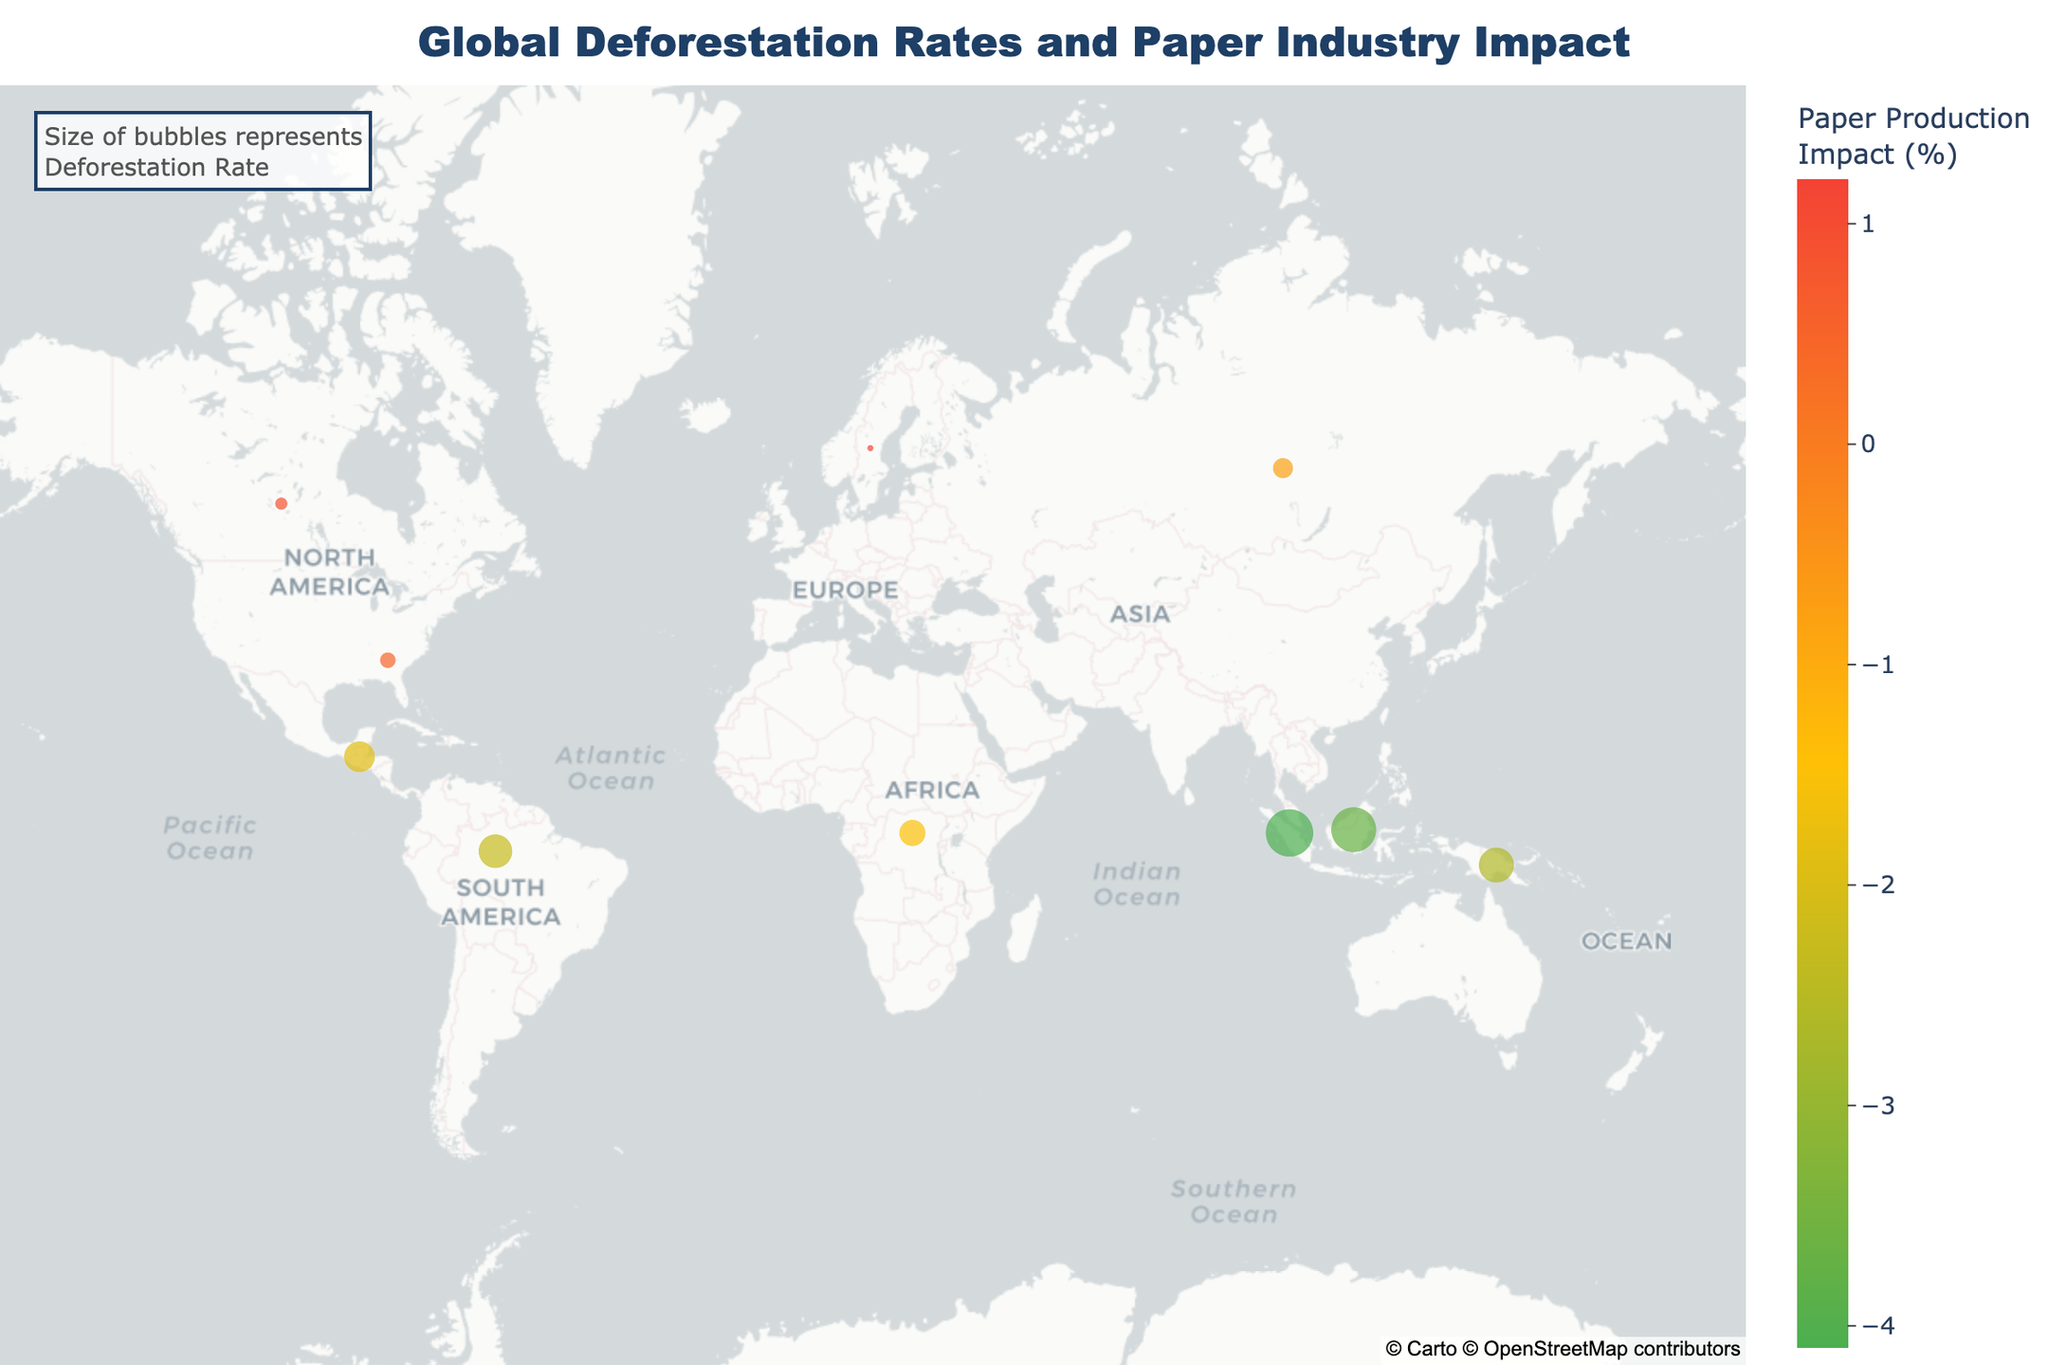What is the title of the figure? The title is usually displayed prominently at the top of the figure. In this case, it reads "Global Deforestation Rates and Paper Industry Impact".
Answer: Global Deforestation Rates and Paper Industry Impact How many regions are shown in the figure? By counting the number of different regions listed in the data or on the map, you can determine the number of regions.
Answer: 10 Which region has the highest deforestation rate? By looking at the size of the bubbles, the largest bubble represents the highest deforestation rate. According to the data, Sumatran Rainforest has the highest deforestation rate at 0.96%.
Answer: Sumatran Rainforest Which region has the lowest impact on paper production? By looking at the color of the bubbles, the least intense color indicates the lowest impact on paper production. The Scandinavian Forests have an impact of 1.2%, which visually looks like the most positive impact (in terms of more saturation). To find the lowest in terms of negative impact, Sumatran Rainforest has the highest negative impact at -4.1%.
Answer: Sumatran Rainforest What's the deforestation rate for the Amazon Rainforest? By hovering over the Amazon Rainforest region on the map or checking the data directly, you can find the deforestation rate.
Answer: 0.49% Which regions have an impact on paper production greater than negative 3%? Filtering through the data, we find the regions with an impact greater than -3%. This includes Amazon Rainforest (-2.3%), Congo Basin (-1.5%), Southeast USA (0.5%), Scandinavian Forests (1.2%), and Canadian Boreal Forest (0.9%).
Answer: Amazon Rainforest, Congo Basin, Southeast USA, Scandinavian Forests, Canadian Boreal Forest How does the deforestation rate of Southeastern USA compare to Borneo? Comparing the deforestation rates from the data, we find that Southeastern USA has a lower deforestation rate (0.11%) compared to Borneo (0.86%).
Answer: Southeastern USA has a lower deforestation rate than Borneo What is the median deforestation rate across all regions? Ordering the deforestation rates (0.02%, 0.07%, 0.11%, 0.18%, 0.3%, 0.41%, 0.49%, 0.53%, 0.86%, 0.96%) and finding the middle value(s), the median is the average of the 5th and 6th values (0.3% and 0.41%), which is (0.3 + 0.41)/2.
Answer: 0.355% Which region has the highest positive impact on paper production? By looking at the colors, the most intense color (saturation) represents the highest positive impact. Scandinavian Forests have an impact of 1.2%, which is the highest positive value in the data.
Answer: Scandinavian Forests Do regions with higher deforestation rates always have higher negative impacts on paper production? By examining the relationship between deforestation rates and paper production impact in the data, it is clear that regions with higher deforestation rates do tend to have higher negative impacts (e.g., Sumatran Rainforest: 0.96% deforestation, -4.1% impact). However, this is not always consistent; regions like Southeast USA have low rates and a positive impact.
Answer: No 